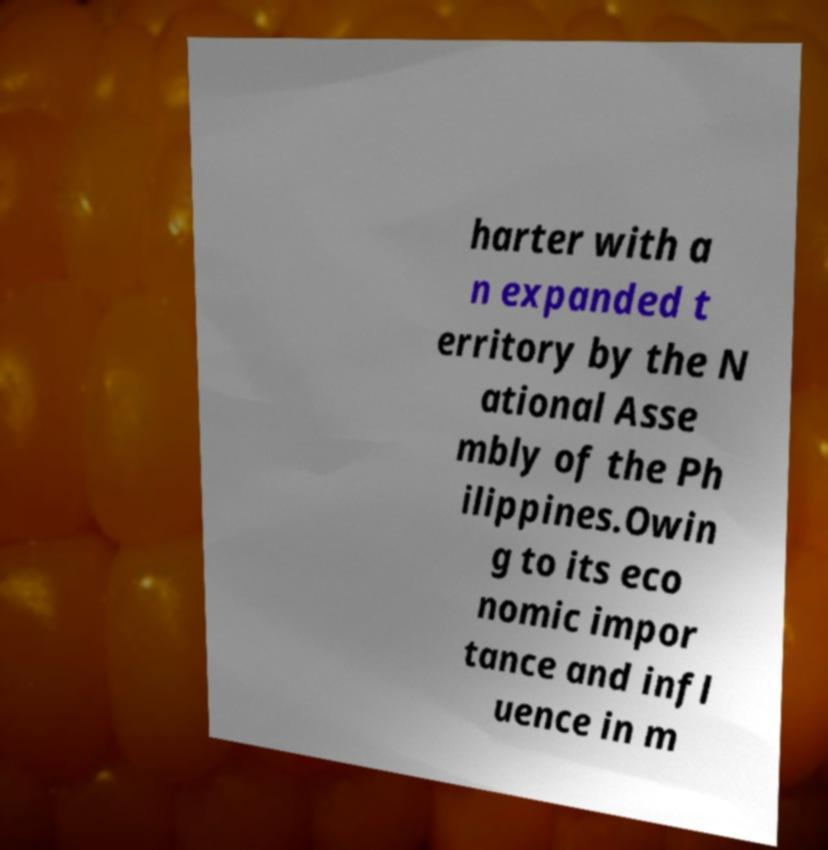Could you extract and type out the text from this image? harter with a n expanded t erritory by the N ational Asse mbly of the Ph ilippines.Owin g to its eco nomic impor tance and infl uence in m 